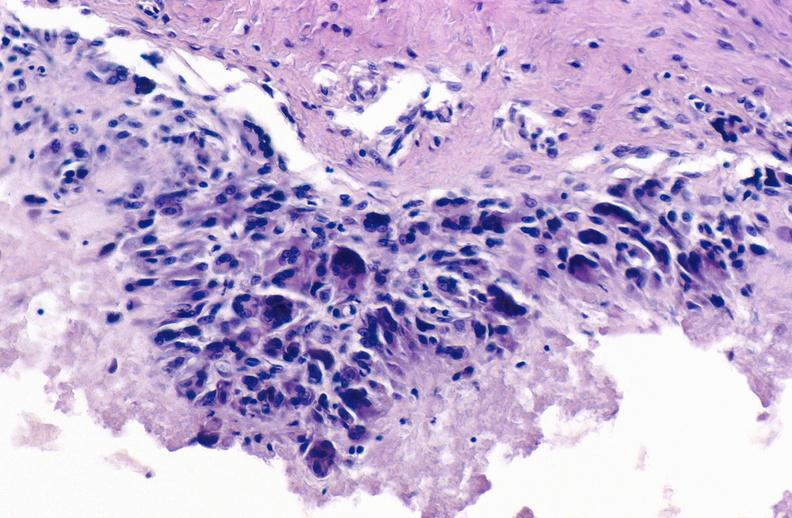s joints present?
Answer the question using a single word or phrase. Yes 